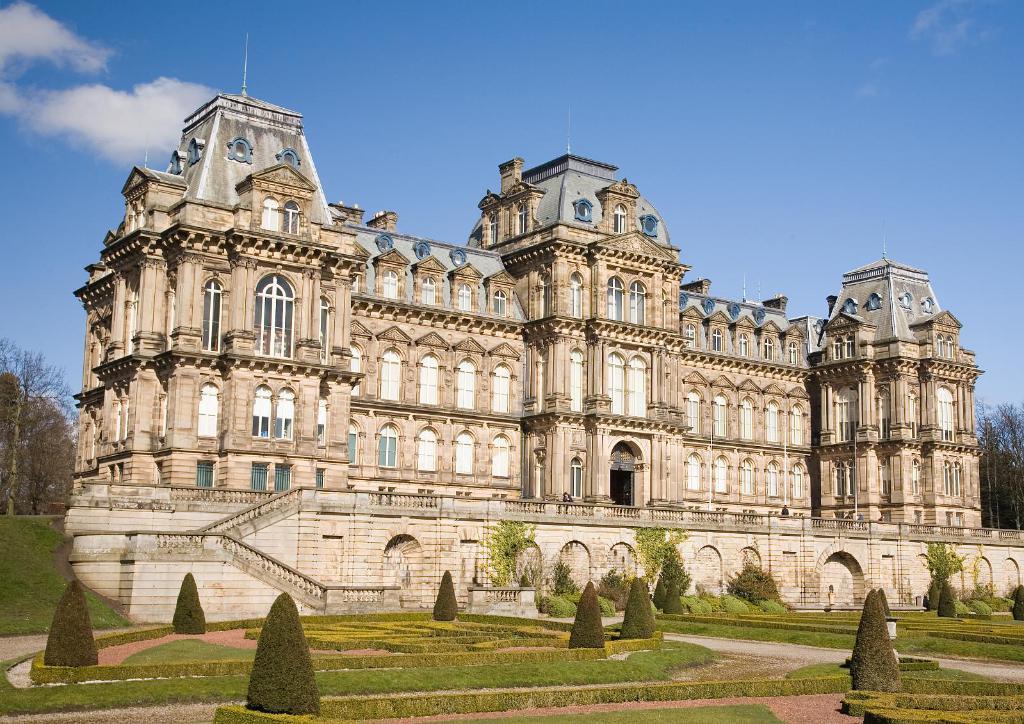Please provide a concise description of this image. In this image I can see a fort , in front of fort I can see bushes and plants at the top I can see the sky. 